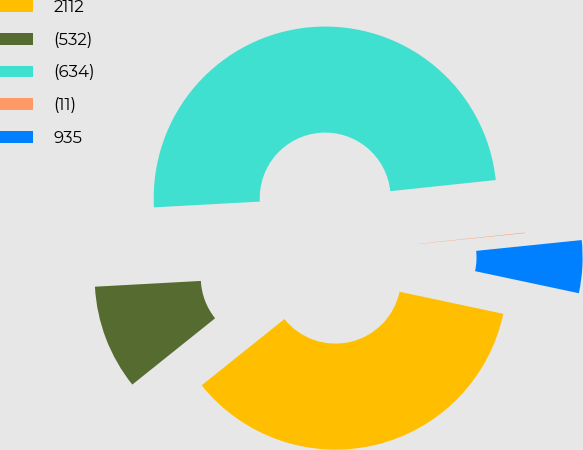Convert chart. <chart><loc_0><loc_0><loc_500><loc_500><pie_chart><fcel>2112<fcel>(532)<fcel>(634)<fcel>(11)<fcel>935<nl><fcel>35.92%<fcel>9.88%<fcel>49.19%<fcel>0.05%<fcel>4.96%<nl></chart> 